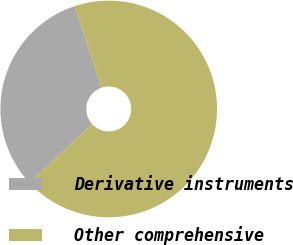Convert chart to OTSL. <chart><loc_0><loc_0><loc_500><loc_500><pie_chart><fcel>Derivative instruments<fcel>Other comprehensive<nl><fcel>31.82%<fcel>68.18%<nl></chart> 